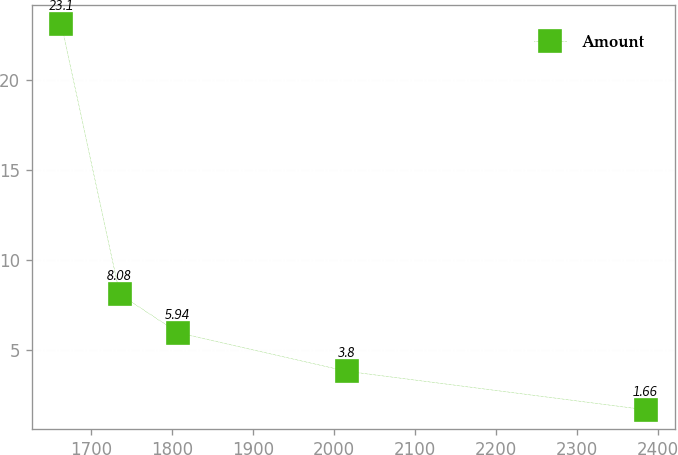Convert chart to OTSL. <chart><loc_0><loc_0><loc_500><loc_500><line_chart><ecel><fcel>Amount<nl><fcel>1663.61<fcel>23.1<nl><fcel>1735.76<fcel>8.08<nl><fcel>1807.91<fcel>5.94<nl><fcel>2015.97<fcel>3.8<nl><fcel>2385.11<fcel>1.66<nl></chart> 